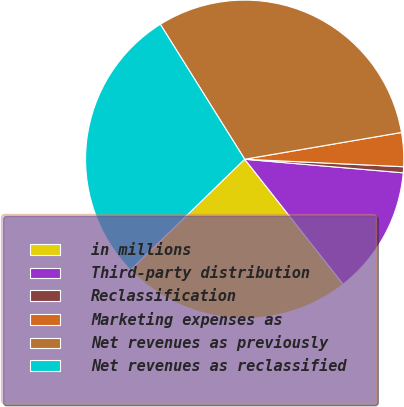<chart> <loc_0><loc_0><loc_500><loc_500><pie_chart><fcel>in millions<fcel>Third-party distribution<fcel>Reclassification<fcel>Marketing expenses as<fcel>Net revenues as previously<fcel>Net revenues as reclassified<nl><fcel>23.36%<fcel>13.02%<fcel>0.61%<fcel>3.44%<fcel>31.2%<fcel>28.36%<nl></chart> 